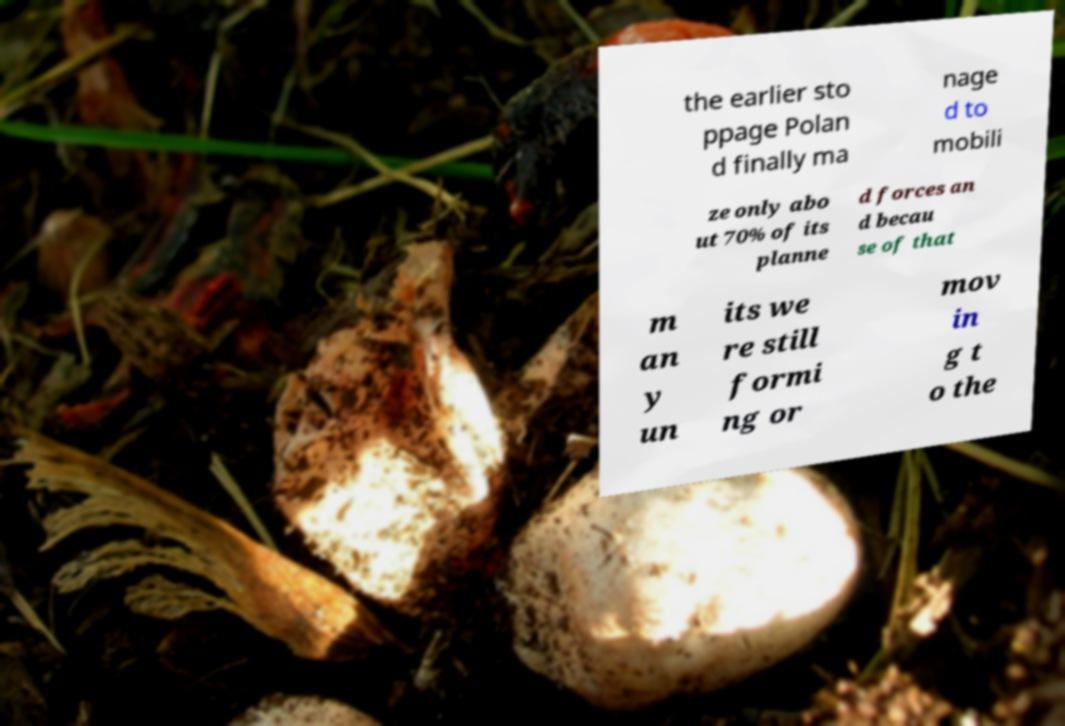Can you read and provide the text displayed in the image?This photo seems to have some interesting text. Can you extract and type it out for me? the earlier sto ppage Polan d finally ma nage d to mobili ze only abo ut 70% of its planne d forces an d becau se of that m an y un its we re still formi ng or mov in g t o the 